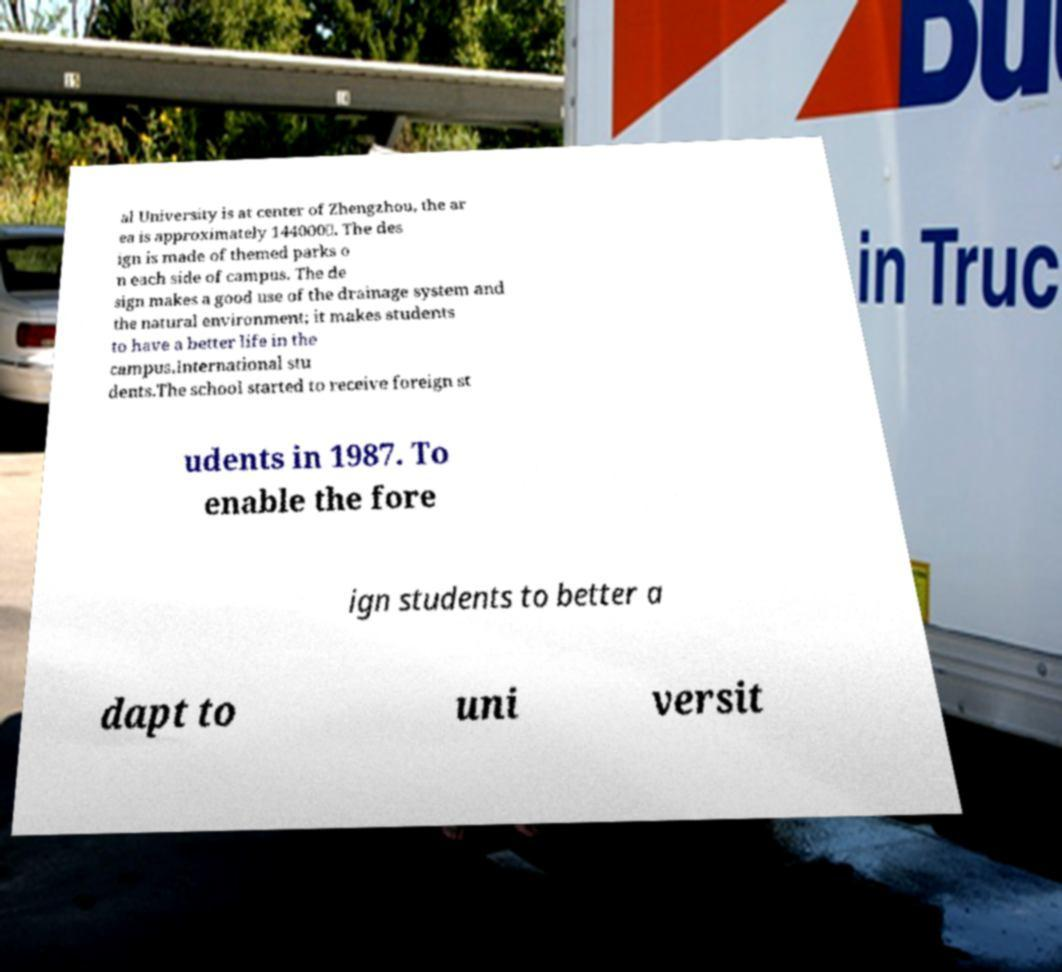For documentation purposes, I need the text within this image transcribed. Could you provide that? al University is at center of Zhengzhou, the ar ea is approximately 144000㎡. The des ign is made of themed parks o n each side of campus. The de sign makes a good use of the drainage system and the natural environment; it makes students to have a better life in the campus.International stu dents.The school started to receive foreign st udents in 1987. To enable the fore ign students to better a dapt to uni versit 